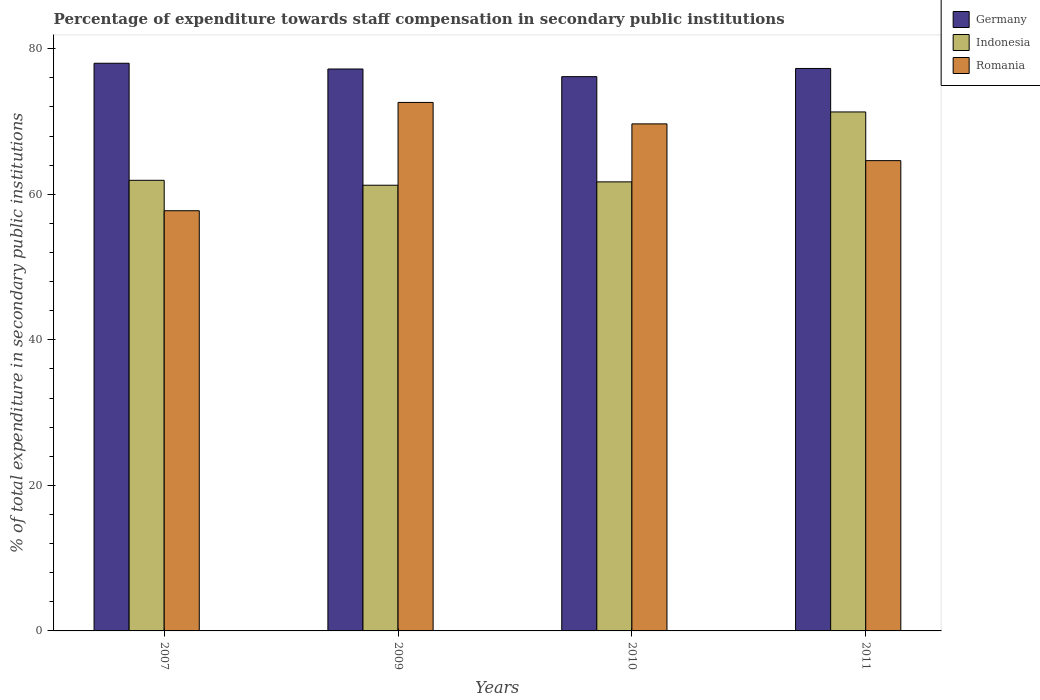How many groups of bars are there?
Keep it short and to the point. 4. What is the label of the 1st group of bars from the left?
Your response must be concise. 2007. In how many cases, is the number of bars for a given year not equal to the number of legend labels?
Offer a very short reply. 0. What is the percentage of expenditure towards staff compensation in Indonesia in 2010?
Your answer should be very brief. 61.7. Across all years, what is the maximum percentage of expenditure towards staff compensation in Indonesia?
Ensure brevity in your answer.  71.31. Across all years, what is the minimum percentage of expenditure towards staff compensation in Romania?
Offer a terse response. 57.73. What is the total percentage of expenditure towards staff compensation in Romania in the graph?
Provide a short and direct response. 264.64. What is the difference between the percentage of expenditure towards staff compensation in Romania in 2007 and that in 2011?
Make the answer very short. -6.88. What is the difference between the percentage of expenditure towards staff compensation in Germany in 2011 and the percentage of expenditure towards staff compensation in Romania in 2009?
Your answer should be very brief. 4.67. What is the average percentage of expenditure towards staff compensation in Germany per year?
Keep it short and to the point. 77.16. In the year 2010, what is the difference between the percentage of expenditure towards staff compensation in Germany and percentage of expenditure towards staff compensation in Indonesia?
Make the answer very short. 14.46. In how many years, is the percentage of expenditure towards staff compensation in Romania greater than 40 %?
Your answer should be compact. 4. What is the ratio of the percentage of expenditure towards staff compensation in Indonesia in 2007 to that in 2011?
Make the answer very short. 0.87. Is the difference between the percentage of expenditure towards staff compensation in Germany in 2007 and 2009 greater than the difference between the percentage of expenditure towards staff compensation in Indonesia in 2007 and 2009?
Keep it short and to the point. Yes. What is the difference between the highest and the second highest percentage of expenditure towards staff compensation in Germany?
Your answer should be compact. 0.72. What is the difference between the highest and the lowest percentage of expenditure towards staff compensation in Germany?
Offer a very short reply. 1.84. In how many years, is the percentage of expenditure towards staff compensation in Romania greater than the average percentage of expenditure towards staff compensation in Romania taken over all years?
Make the answer very short. 2. What does the 2nd bar from the left in 2009 represents?
Offer a very short reply. Indonesia. Is it the case that in every year, the sum of the percentage of expenditure towards staff compensation in Indonesia and percentage of expenditure towards staff compensation in Romania is greater than the percentage of expenditure towards staff compensation in Germany?
Your response must be concise. Yes. Are all the bars in the graph horizontal?
Your answer should be compact. No. How many years are there in the graph?
Make the answer very short. 4. Are the values on the major ticks of Y-axis written in scientific E-notation?
Your answer should be very brief. No. Does the graph contain any zero values?
Provide a succinct answer. No. Does the graph contain grids?
Ensure brevity in your answer.  No. Where does the legend appear in the graph?
Your response must be concise. Top right. What is the title of the graph?
Provide a succinct answer. Percentage of expenditure towards staff compensation in secondary public institutions. Does "Mauritius" appear as one of the legend labels in the graph?
Your response must be concise. No. What is the label or title of the Y-axis?
Your response must be concise. % of total expenditure in secondary public institutions. What is the % of total expenditure in secondary public institutions in Germany in 2007?
Make the answer very short. 78. What is the % of total expenditure in secondary public institutions of Indonesia in 2007?
Provide a short and direct response. 61.92. What is the % of total expenditure in secondary public institutions of Romania in 2007?
Provide a short and direct response. 57.73. What is the % of total expenditure in secondary public institutions of Germany in 2009?
Provide a short and direct response. 77.21. What is the % of total expenditure in secondary public institutions in Indonesia in 2009?
Your answer should be compact. 61.24. What is the % of total expenditure in secondary public institutions of Romania in 2009?
Your answer should be compact. 72.62. What is the % of total expenditure in secondary public institutions in Germany in 2010?
Provide a short and direct response. 76.16. What is the % of total expenditure in secondary public institutions in Indonesia in 2010?
Offer a terse response. 61.7. What is the % of total expenditure in secondary public institutions of Romania in 2010?
Ensure brevity in your answer.  69.67. What is the % of total expenditure in secondary public institutions in Germany in 2011?
Keep it short and to the point. 77.28. What is the % of total expenditure in secondary public institutions in Indonesia in 2011?
Provide a succinct answer. 71.31. What is the % of total expenditure in secondary public institutions in Romania in 2011?
Your answer should be compact. 64.62. Across all years, what is the maximum % of total expenditure in secondary public institutions in Germany?
Your answer should be compact. 78. Across all years, what is the maximum % of total expenditure in secondary public institutions of Indonesia?
Offer a very short reply. 71.31. Across all years, what is the maximum % of total expenditure in secondary public institutions of Romania?
Ensure brevity in your answer.  72.62. Across all years, what is the minimum % of total expenditure in secondary public institutions in Germany?
Offer a very short reply. 76.16. Across all years, what is the minimum % of total expenditure in secondary public institutions of Indonesia?
Make the answer very short. 61.24. Across all years, what is the minimum % of total expenditure in secondary public institutions in Romania?
Your response must be concise. 57.73. What is the total % of total expenditure in secondary public institutions in Germany in the graph?
Your response must be concise. 308.65. What is the total % of total expenditure in secondary public institutions in Indonesia in the graph?
Make the answer very short. 256.17. What is the total % of total expenditure in secondary public institutions of Romania in the graph?
Provide a succinct answer. 264.64. What is the difference between the % of total expenditure in secondary public institutions in Germany in 2007 and that in 2009?
Your answer should be very brief. 0.79. What is the difference between the % of total expenditure in secondary public institutions in Indonesia in 2007 and that in 2009?
Offer a terse response. 0.68. What is the difference between the % of total expenditure in secondary public institutions of Romania in 2007 and that in 2009?
Ensure brevity in your answer.  -14.88. What is the difference between the % of total expenditure in secondary public institutions of Germany in 2007 and that in 2010?
Provide a short and direct response. 1.84. What is the difference between the % of total expenditure in secondary public institutions in Indonesia in 2007 and that in 2010?
Provide a succinct answer. 0.21. What is the difference between the % of total expenditure in secondary public institutions in Romania in 2007 and that in 2010?
Provide a succinct answer. -11.93. What is the difference between the % of total expenditure in secondary public institutions in Germany in 2007 and that in 2011?
Your answer should be compact. 0.72. What is the difference between the % of total expenditure in secondary public institutions in Indonesia in 2007 and that in 2011?
Offer a terse response. -9.39. What is the difference between the % of total expenditure in secondary public institutions in Romania in 2007 and that in 2011?
Make the answer very short. -6.88. What is the difference between the % of total expenditure in secondary public institutions in Germany in 2009 and that in 2010?
Your answer should be compact. 1.05. What is the difference between the % of total expenditure in secondary public institutions of Indonesia in 2009 and that in 2010?
Make the answer very short. -0.46. What is the difference between the % of total expenditure in secondary public institutions in Romania in 2009 and that in 2010?
Keep it short and to the point. 2.95. What is the difference between the % of total expenditure in secondary public institutions of Germany in 2009 and that in 2011?
Give a very brief answer. -0.07. What is the difference between the % of total expenditure in secondary public institutions of Indonesia in 2009 and that in 2011?
Provide a succinct answer. -10.07. What is the difference between the % of total expenditure in secondary public institutions in Romania in 2009 and that in 2011?
Provide a succinct answer. 8. What is the difference between the % of total expenditure in secondary public institutions of Germany in 2010 and that in 2011?
Your answer should be very brief. -1.12. What is the difference between the % of total expenditure in secondary public institutions of Indonesia in 2010 and that in 2011?
Provide a succinct answer. -9.61. What is the difference between the % of total expenditure in secondary public institutions in Romania in 2010 and that in 2011?
Your response must be concise. 5.05. What is the difference between the % of total expenditure in secondary public institutions of Germany in 2007 and the % of total expenditure in secondary public institutions of Indonesia in 2009?
Keep it short and to the point. 16.76. What is the difference between the % of total expenditure in secondary public institutions of Germany in 2007 and the % of total expenditure in secondary public institutions of Romania in 2009?
Provide a succinct answer. 5.38. What is the difference between the % of total expenditure in secondary public institutions of Indonesia in 2007 and the % of total expenditure in secondary public institutions of Romania in 2009?
Provide a succinct answer. -10.7. What is the difference between the % of total expenditure in secondary public institutions of Germany in 2007 and the % of total expenditure in secondary public institutions of Indonesia in 2010?
Offer a terse response. 16.3. What is the difference between the % of total expenditure in secondary public institutions of Germany in 2007 and the % of total expenditure in secondary public institutions of Romania in 2010?
Provide a short and direct response. 8.33. What is the difference between the % of total expenditure in secondary public institutions of Indonesia in 2007 and the % of total expenditure in secondary public institutions of Romania in 2010?
Provide a succinct answer. -7.75. What is the difference between the % of total expenditure in secondary public institutions of Germany in 2007 and the % of total expenditure in secondary public institutions of Indonesia in 2011?
Give a very brief answer. 6.69. What is the difference between the % of total expenditure in secondary public institutions of Germany in 2007 and the % of total expenditure in secondary public institutions of Romania in 2011?
Your response must be concise. 13.38. What is the difference between the % of total expenditure in secondary public institutions in Indonesia in 2007 and the % of total expenditure in secondary public institutions in Romania in 2011?
Offer a terse response. -2.7. What is the difference between the % of total expenditure in secondary public institutions of Germany in 2009 and the % of total expenditure in secondary public institutions of Indonesia in 2010?
Make the answer very short. 15.51. What is the difference between the % of total expenditure in secondary public institutions of Germany in 2009 and the % of total expenditure in secondary public institutions of Romania in 2010?
Provide a short and direct response. 7.54. What is the difference between the % of total expenditure in secondary public institutions of Indonesia in 2009 and the % of total expenditure in secondary public institutions of Romania in 2010?
Provide a short and direct response. -8.43. What is the difference between the % of total expenditure in secondary public institutions in Germany in 2009 and the % of total expenditure in secondary public institutions in Indonesia in 2011?
Offer a very short reply. 5.9. What is the difference between the % of total expenditure in secondary public institutions in Germany in 2009 and the % of total expenditure in secondary public institutions in Romania in 2011?
Provide a short and direct response. 12.59. What is the difference between the % of total expenditure in secondary public institutions in Indonesia in 2009 and the % of total expenditure in secondary public institutions in Romania in 2011?
Provide a short and direct response. -3.38. What is the difference between the % of total expenditure in secondary public institutions in Germany in 2010 and the % of total expenditure in secondary public institutions in Indonesia in 2011?
Offer a very short reply. 4.85. What is the difference between the % of total expenditure in secondary public institutions in Germany in 2010 and the % of total expenditure in secondary public institutions in Romania in 2011?
Ensure brevity in your answer.  11.54. What is the difference between the % of total expenditure in secondary public institutions in Indonesia in 2010 and the % of total expenditure in secondary public institutions in Romania in 2011?
Provide a short and direct response. -2.92. What is the average % of total expenditure in secondary public institutions in Germany per year?
Offer a terse response. 77.16. What is the average % of total expenditure in secondary public institutions in Indonesia per year?
Your answer should be compact. 64.04. What is the average % of total expenditure in secondary public institutions of Romania per year?
Give a very brief answer. 66.16. In the year 2007, what is the difference between the % of total expenditure in secondary public institutions in Germany and % of total expenditure in secondary public institutions in Indonesia?
Give a very brief answer. 16.08. In the year 2007, what is the difference between the % of total expenditure in secondary public institutions of Germany and % of total expenditure in secondary public institutions of Romania?
Make the answer very short. 20.26. In the year 2007, what is the difference between the % of total expenditure in secondary public institutions in Indonesia and % of total expenditure in secondary public institutions in Romania?
Your response must be concise. 4.18. In the year 2009, what is the difference between the % of total expenditure in secondary public institutions in Germany and % of total expenditure in secondary public institutions in Indonesia?
Make the answer very short. 15.97. In the year 2009, what is the difference between the % of total expenditure in secondary public institutions in Germany and % of total expenditure in secondary public institutions in Romania?
Give a very brief answer. 4.59. In the year 2009, what is the difference between the % of total expenditure in secondary public institutions in Indonesia and % of total expenditure in secondary public institutions in Romania?
Offer a terse response. -11.38. In the year 2010, what is the difference between the % of total expenditure in secondary public institutions in Germany and % of total expenditure in secondary public institutions in Indonesia?
Provide a short and direct response. 14.46. In the year 2010, what is the difference between the % of total expenditure in secondary public institutions of Germany and % of total expenditure in secondary public institutions of Romania?
Your response must be concise. 6.49. In the year 2010, what is the difference between the % of total expenditure in secondary public institutions in Indonesia and % of total expenditure in secondary public institutions in Romania?
Provide a short and direct response. -7.97. In the year 2011, what is the difference between the % of total expenditure in secondary public institutions in Germany and % of total expenditure in secondary public institutions in Indonesia?
Keep it short and to the point. 5.97. In the year 2011, what is the difference between the % of total expenditure in secondary public institutions in Germany and % of total expenditure in secondary public institutions in Romania?
Ensure brevity in your answer.  12.66. In the year 2011, what is the difference between the % of total expenditure in secondary public institutions in Indonesia and % of total expenditure in secondary public institutions in Romania?
Provide a succinct answer. 6.69. What is the ratio of the % of total expenditure in secondary public institutions in Germany in 2007 to that in 2009?
Provide a succinct answer. 1.01. What is the ratio of the % of total expenditure in secondary public institutions of Indonesia in 2007 to that in 2009?
Your answer should be compact. 1.01. What is the ratio of the % of total expenditure in secondary public institutions of Romania in 2007 to that in 2009?
Provide a succinct answer. 0.8. What is the ratio of the % of total expenditure in secondary public institutions in Germany in 2007 to that in 2010?
Provide a short and direct response. 1.02. What is the ratio of the % of total expenditure in secondary public institutions of Romania in 2007 to that in 2010?
Offer a terse response. 0.83. What is the ratio of the % of total expenditure in secondary public institutions of Germany in 2007 to that in 2011?
Ensure brevity in your answer.  1.01. What is the ratio of the % of total expenditure in secondary public institutions in Indonesia in 2007 to that in 2011?
Make the answer very short. 0.87. What is the ratio of the % of total expenditure in secondary public institutions in Romania in 2007 to that in 2011?
Give a very brief answer. 0.89. What is the ratio of the % of total expenditure in secondary public institutions in Germany in 2009 to that in 2010?
Provide a succinct answer. 1.01. What is the ratio of the % of total expenditure in secondary public institutions in Indonesia in 2009 to that in 2010?
Your answer should be compact. 0.99. What is the ratio of the % of total expenditure in secondary public institutions of Romania in 2009 to that in 2010?
Make the answer very short. 1.04. What is the ratio of the % of total expenditure in secondary public institutions of Germany in 2009 to that in 2011?
Give a very brief answer. 1. What is the ratio of the % of total expenditure in secondary public institutions of Indonesia in 2009 to that in 2011?
Your answer should be compact. 0.86. What is the ratio of the % of total expenditure in secondary public institutions in Romania in 2009 to that in 2011?
Give a very brief answer. 1.12. What is the ratio of the % of total expenditure in secondary public institutions in Germany in 2010 to that in 2011?
Your answer should be compact. 0.99. What is the ratio of the % of total expenditure in secondary public institutions of Indonesia in 2010 to that in 2011?
Give a very brief answer. 0.87. What is the ratio of the % of total expenditure in secondary public institutions in Romania in 2010 to that in 2011?
Your answer should be compact. 1.08. What is the difference between the highest and the second highest % of total expenditure in secondary public institutions of Germany?
Your response must be concise. 0.72. What is the difference between the highest and the second highest % of total expenditure in secondary public institutions of Indonesia?
Keep it short and to the point. 9.39. What is the difference between the highest and the second highest % of total expenditure in secondary public institutions in Romania?
Make the answer very short. 2.95. What is the difference between the highest and the lowest % of total expenditure in secondary public institutions of Germany?
Give a very brief answer. 1.84. What is the difference between the highest and the lowest % of total expenditure in secondary public institutions in Indonesia?
Offer a very short reply. 10.07. What is the difference between the highest and the lowest % of total expenditure in secondary public institutions of Romania?
Provide a succinct answer. 14.88. 